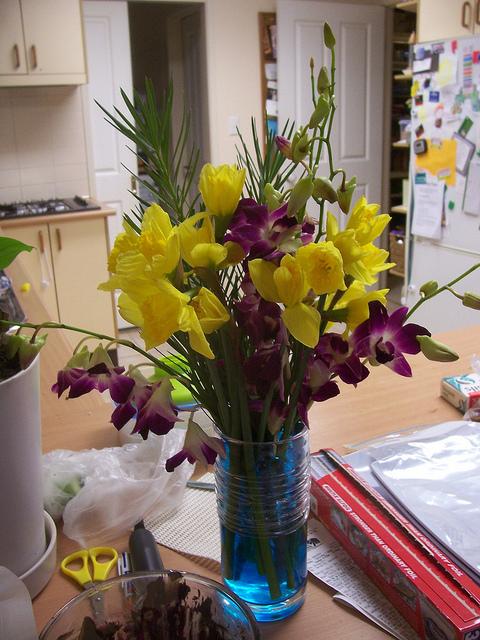What colors are the flowers?
Answer briefly. Yellow. What are the yellow flowers called in the vase?
Concise answer only. Tulips. What color are the tulips?
Keep it brief. Yellow. Has the water in the vase been mixed with food coloring?
Keep it brief. Yes. How many purple flowers are there?
Give a very brief answer. 3. Does this look like a floral arrangement you would buy from a florist?
Write a very short answer. Yes. What are the white folded items in the glasses in the background?
Answer briefly. Napkins. Where are the books?
Concise answer only. Table. Do all the daffodils share one vase?
Write a very short answer. Yes. What color is the flowers?
Concise answer only. Yellow. Are the scissors the same color as the flower?
Give a very brief answer. Yes. What color is the vase?
Keep it brief. Blue. Where are magnets?
Quick response, please. Fridge. What are the two types of colors of flowers?
Keep it brief. Yellow and purple. Are all daffodils yellow?
Keep it brief. Yes. What are the flowers in?
Give a very brief answer. Vase. What color are the vases?
Keep it brief. Blue. 